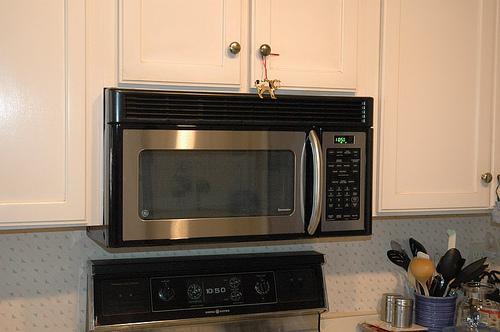What are the utensils for?
Write a very short answer. Cooking. What appliance is this?
Write a very short answer. Microwave. Where are the utensils?
Short answer required. Yes. What color are the cabinets?
Keep it brief. White. 